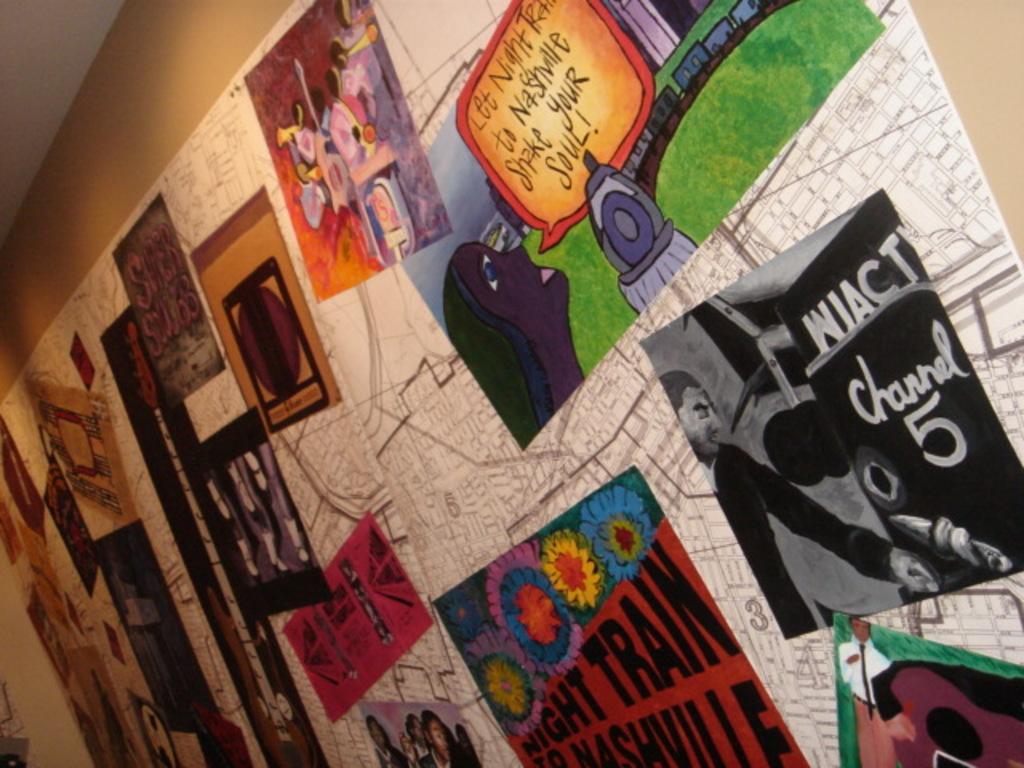What is the quote the lady is saying?
Your answer should be compact. Let night train to nashville shake your soul!. 